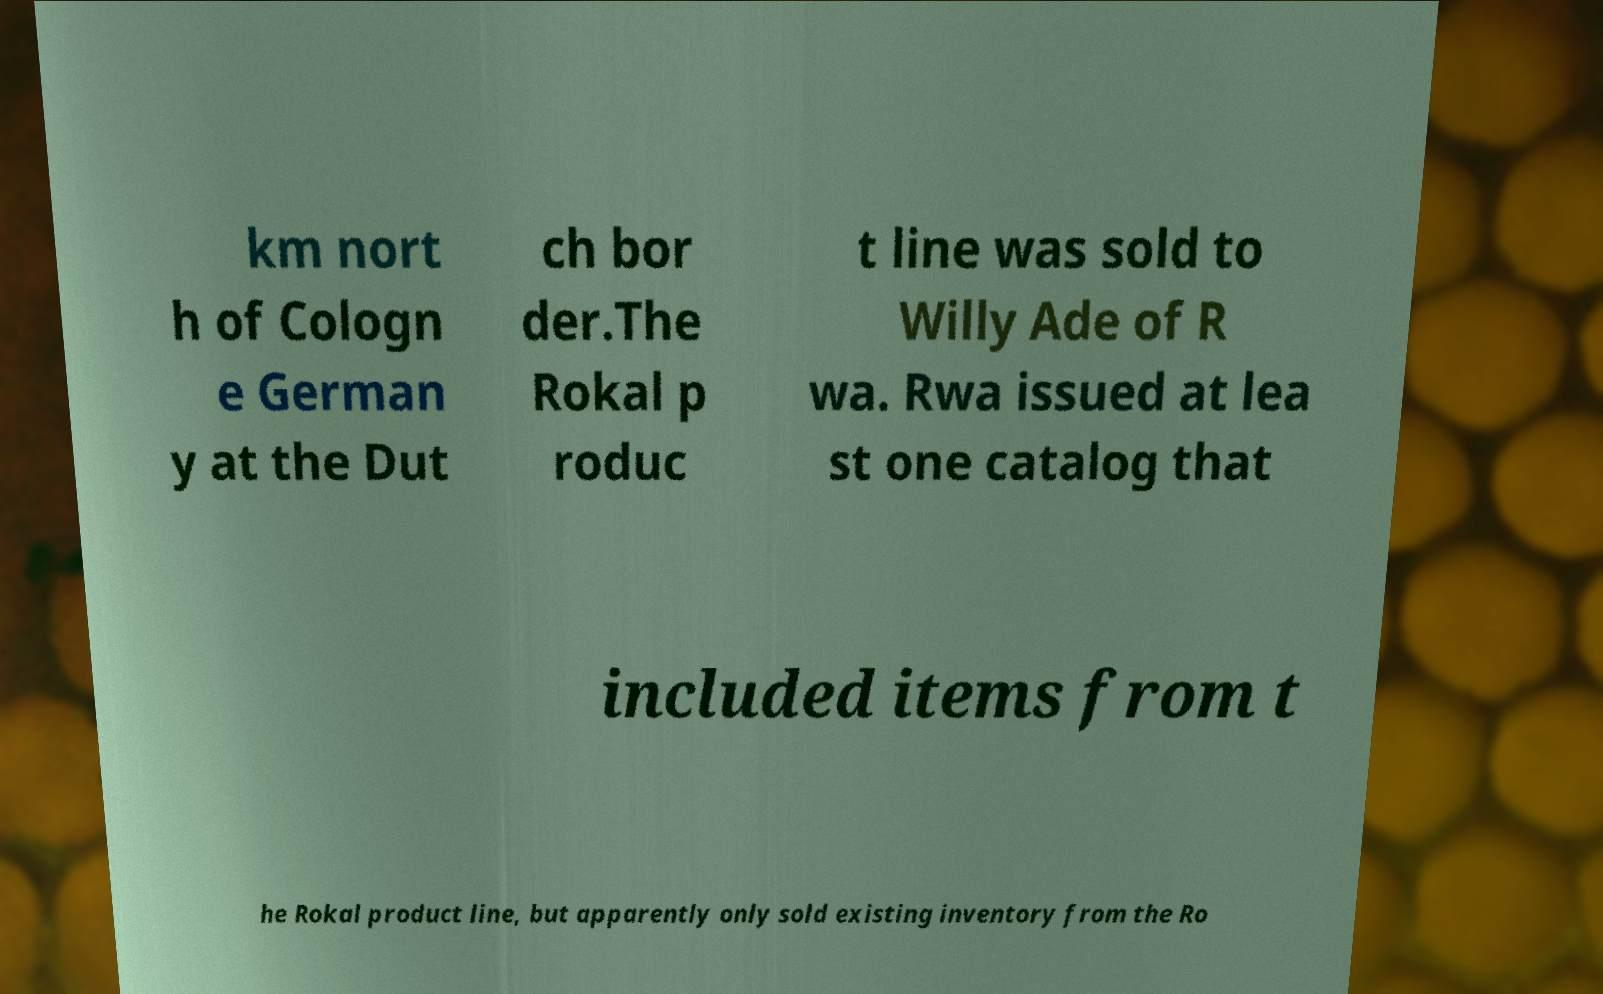Could you assist in decoding the text presented in this image and type it out clearly? km nort h of Cologn e German y at the Dut ch bor der.The Rokal p roduc t line was sold to Willy Ade of R wa. Rwa issued at lea st one catalog that included items from t he Rokal product line, but apparently only sold existing inventory from the Ro 